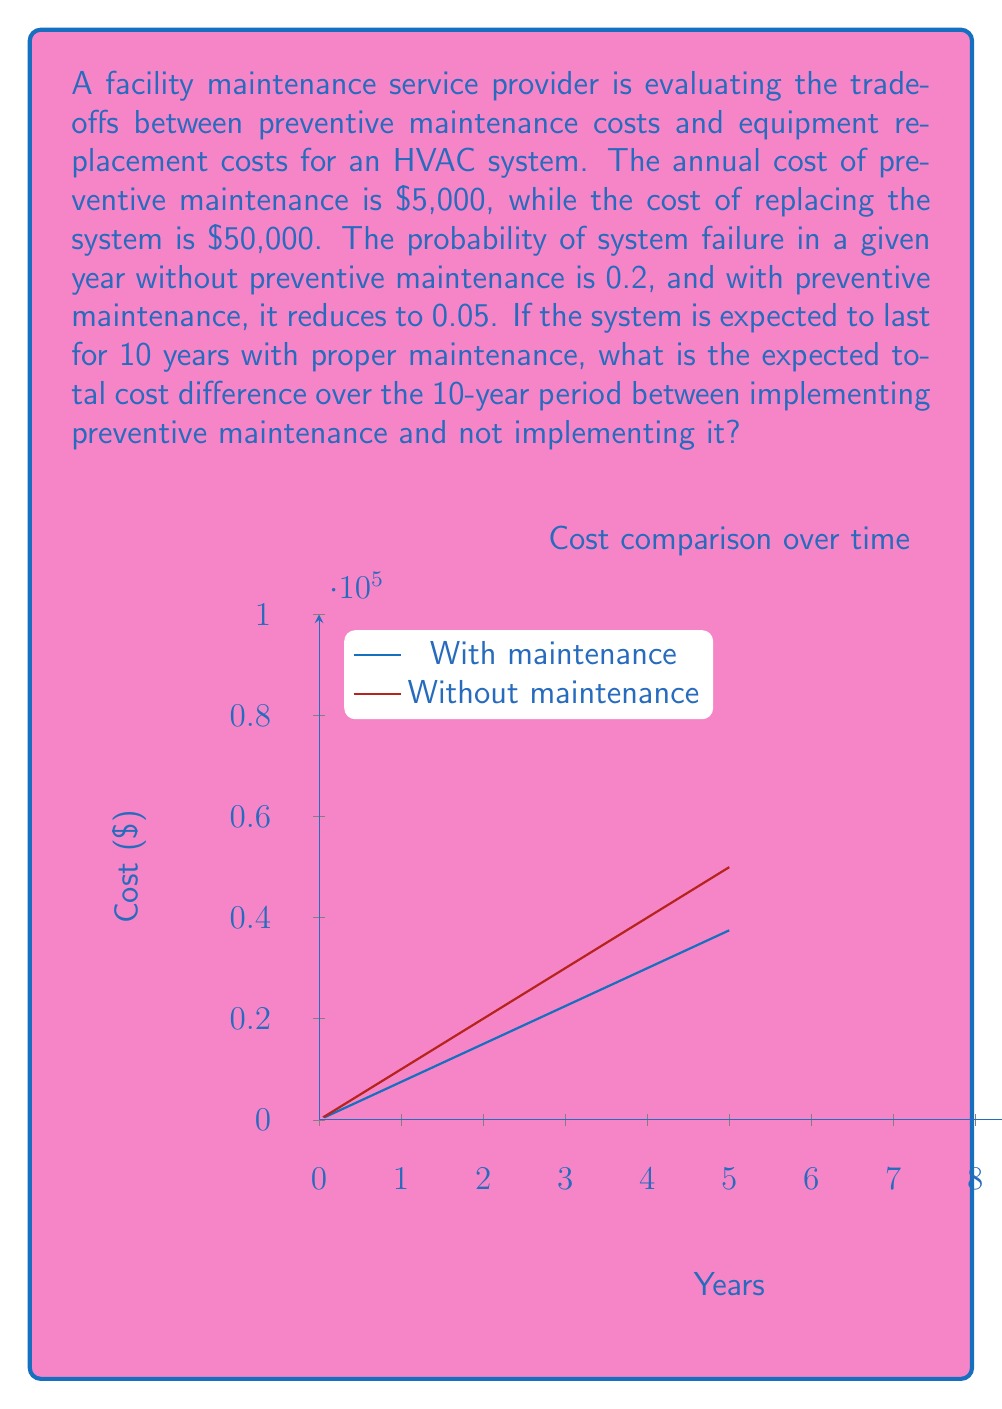Can you solve this math problem? Let's approach this step-by-step:

1) First, let's calculate the expected cost over 10 years with preventive maintenance:
   
   Annual cost = Maintenance cost + (Probability of failure × Replacement cost)
   $$5000 + (0.05 × 50000) = 7500$$
   
   Total cost over 10 years: $$10 × 7500 = 75000$$

2) Now, let's calculate the expected cost over 10 years without preventive maintenance:
   
   Annual cost = Probability of failure × Replacement cost
   $$0.2 × 50000 = 10000$$
   
   Total cost over 10 years: $$10 × 10000 = 100000$$

3) To find the difference, we subtract:
   $$100000 - 75000 = 25000$$

Therefore, the expected total cost difference over the 10-year period is $25,000 in favor of implementing preventive maintenance.

This result shows that despite the annual cost of preventive maintenance, it is expected to save money in the long run due to the reduced probability of system failure and subsequent replacement costs.
Answer: $25,000 